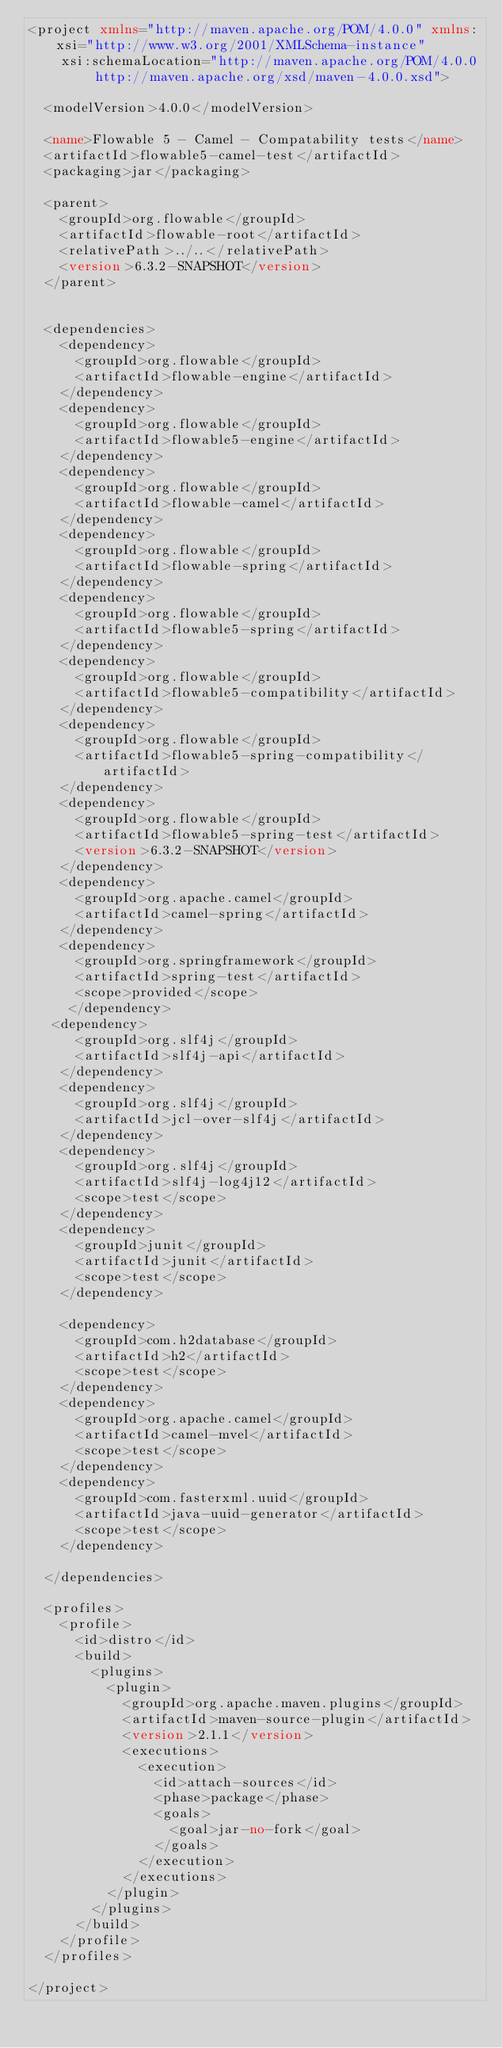<code> <loc_0><loc_0><loc_500><loc_500><_XML_><project xmlns="http://maven.apache.org/POM/4.0.0" xmlns:xsi="http://www.w3.org/2001/XMLSchema-instance"
	xsi:schemaLocation="http://maven.apache.org/POM/4.0.0 http://maven.apache.org/xsd/maven-4.0.0.xsd">

  <modelVersion>4.0.0</modelVersion>

  <name>Flowable 5 - Camel - Compatability tests</name>
  <artifactId>flowable5-camel-test</artifactId>
  <packaging>jar</packaging>

  <parent>
    <groupId>org.flowable</groupId>
    <artifactId>flowable-root</artifactId>
    <relativePath>../..</relativePath>
    <version>6.3.2-SNAPSHOT</version>
  </parent>


  <dependencies>
  	<dependency>
      <groupId>org.flowable</groupId>
      <artifactId>flowable-engine</artifactId>
    </dependency>
    <dependency>
      <groupId>org.flowable</groupId>
      <artifactId>flowable5-engine</artifactId>
    </dependency>
  	<dependency>
      <groupId>org.flowable</groupId>
      <artifactId>flowable-camel</artifactId>
    </dependency>
    <dependency>
      <groupId>org.flowable</groupId>
      <artifactId>flowable-spring</artifactId>
    </dependency>
    <dependency>
      <groupId>org.flowable</groupId>
      <artifactId>flowable5-spring</artifactId>
    </dependency>
    <dependency>
      <groupId>org.flowable</groupId>
      <artifactId>flowable5-compatibility</artifactId>
    </dependency>
    <dependency>
      <groupId>org.flowable</groupId>
      <artifactId>flowable5-spring-compatibility</artifactId>
    </dependency>
    <dependency>
      <groupId>org.flowable</groupId>
      <artifactId>flowable5-spring-test</artifactId>
      <version>6.3.2-SNAPSHOT</version>
    </dependency>
    <dependency>
      <groupId>org.apache.camel</groupId>
      <artifactId>camel-spring</artifactId>
    </dependency>
    <dependency>
      <groupId>org.springframework</groupId>
      <artifactId>spring-test</artifactId>
      <scope>provided</scope>
	 </dependency>
   <dependency>
      <groupId>org.slf4j</groupId>
      <artifactId>slf4j-api</artifactId>
    </dependency>
    <dependency>
      <groupId>org.slf4j</groupId>
      <artifactId>jcl-over-slf4j</artifactId>
    </dependency>
    <dependency>
      <groupId>org.slf4j</groupId>
      <artifactId>slf4j-log4j12</artifactId>
      <scope>test</scope>
    </dependency>
    <dependency>
      <groupId>junit</groupId>
      <artifactId>junit</artifactId>
      <scope>test</scope>
    </dependency>

    <dependency>
      <groupId>com.h2database</groupId>
      <artifactId>h2</artifactId>
      <scope>test</scope>
    </dependency>
    <dependency>
      <groupId>org.apache.camel</groupId>
      <artifactId>camel-mvel</artifactId>
      <scope>test</scope>
    </dependency>
    <dependency>
      <groupId>com.fasterxml.uuid</groupId>
      <artifactId>java-uuid-generator</artifactId>
      <scope>test</scope>
    </dependency>

  </dependencies>

  <profiles>
    <profile>
      <id>distro</id>
      <build>
        <plugins>
          <plugin>
            <groupId>org.apache.maven.plugins</groupId>
            <artifactId>maven-source-plugin</artifactId>
            <version>2.1.1</version>
            <executions>
              <execution>
                <id>attach-sources</id>
                <phase>package</phase>
                <goals>
                  <goal>jar-no-fork</goal>
                </goals>
              </execution>
            </executions>
          </plugin>
        </plugins>
      </build>
    </profile>
  </profiles>

</project>
</code> 